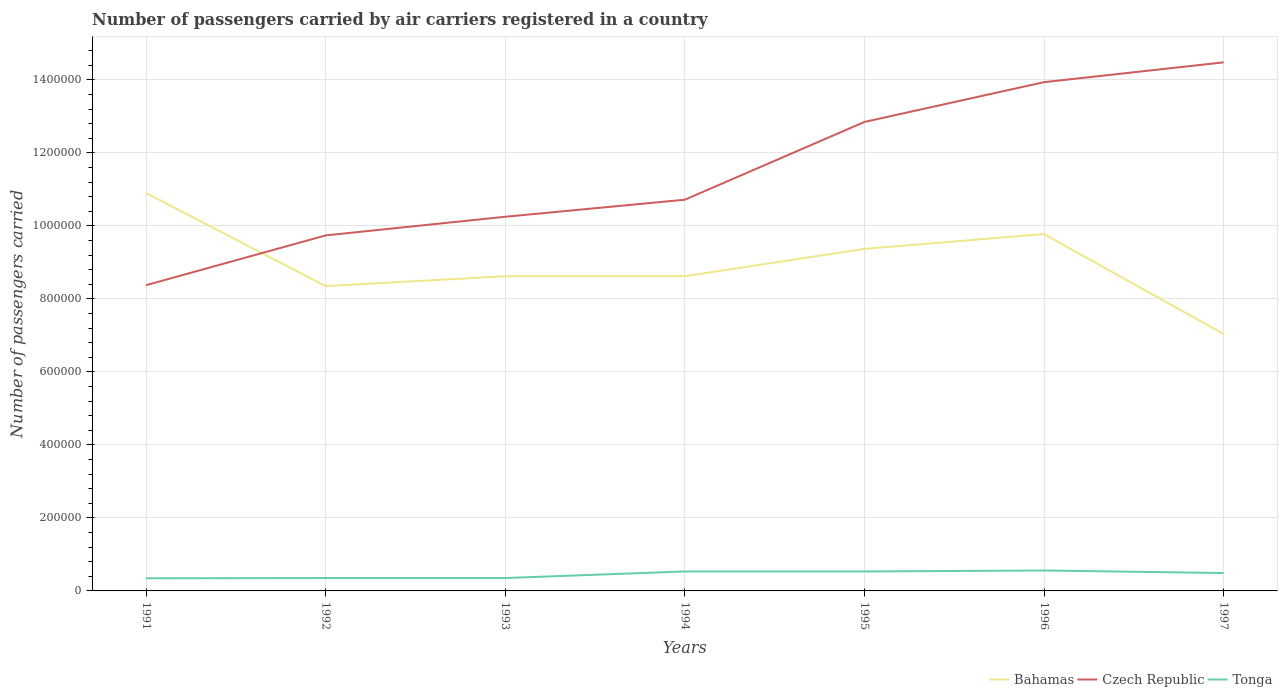How many different coloured lines are there?
Ensure brevity in your answer.  3. Does the line corresponding to Bahamas intersect with the line corresponding to Tonga?
Your response must be concise. No. Is the number of lines equal to the number of legend labels?
Your answer should be compact. Yes. Across all years, what is the maximum number of passengers carried by air carriers in Bahamas?
Provide a succinct answer. 7.04e+05. In which year was the number of passengers carried by air carriers in Bahamas maximum?
Provide a short and direct response. 1997. What is the total number of passengers carried by air carriers in Czech Republic in the graph?
Your answer should be compact. -2.13e+05. What is the difference between the highest and the second highest number of passengers carried by air carriers in Tonga?
Your answer should be compact. 2.14e+04. Is the number of passengers carried by air carriers in Bahamas strictly greater than the number of passengers carried by air carriers in Tonga over the years?
Your answer should be very brief. No. How many lines are there?
Make the answer very short. 3. Does the graph contain any zero values?
Offer a very short reply. No. Does the graph contain grids?
Give a very brief answer. Yes. Where does the legend appear in the graph?
Your response must be concise. Bottom right. What is the title of the graph?
Your answer should be compact. Number of passengers carried by air carriers registered in a country. What is the label or title of the X-axis?
Provide a short and direct response. Years. What is the label or title of the Y-axis?
Ensure brevity in your answer.  Number of passengers carried. What is the Number of passengers carried of Bahamas in 1991?
Keep it short and to the point. 1.09e+06. What is the Number of passengers carried of Czech Republic in 1991?
Provide a succinct answer. 8.37e+05. What is the Number of passengers carried of Tonga in 1991?
Provide a succinct answer. 3.46e+04. What is the Number of passengers carried of Bahamas in 1992?
Make the answer very short. 8.35e+05. What is the Number of passengers carried of Czech Republic in 1992?
Give a very brief answer. 9.74e+05. What is the Number of passengers carried of Tonga in 1992?
Ensure brevity in your answer.  3.53e+04. What is the Number of passengers carried of Bahamas in 1993?
Offer a terse response. 8.62e+05. What is the Number of passengers carried in Czech Republic in 1993?
Give a very brief answer. 1.02e+06. What is the Number of passengers carried of Tonga in 1993?
Offer a terse response. 3.53e+04. What is the Number of passengers carried in Bahamas in 1994?
Your response must be concise. 8.62e+05. What is the Number of passengers carried in Czech Republic in 1994?
Your answer should be compact. 1.07e+06. What is the Number of passengers carried in Tonga in 1994?
Your response must be concise. 5.33e+04. What is the Number of passengers carried of Bahamas in 1995?
Make the answer very short. 9.37e+05. What is the Number of passengers carried in Czech Republic in 1995?
Offer a terse response. 1.28e+06. What is the Number of passengers carried of Tonga in 1995?
Your response must be concise. 5.33e+04. What is the Number of passengers carried in Bahamas in 1996?
Make the answer very short. 9.78e+05. What is the Number of passengers carried in Czech Republic in 1996?
Your answer should be compact. 1.39e+06. What is the Number of passengers carried in Tonga in 1996?
Keep it short and to the point. 5.60e+04. What is the Number of passengers carried of Bahamas in 1997?
Offer a very short reply. 7.04e+05. What is the Number of passengers carried of Czech Republic in 1997?
Your answer should be very brief. 1.45e+06. What is the Number of passengers carried in Tonga in 1997?
Your response must be concise. 4.90e+04. Across all years, what is the maximum Number of passengers carried in Bahamas?
Your answer should be compact. 1.09e+06. Across all years, what is the maximum Number of passengers carried in Czech Republic?
Provide a short and direct response. 1.45e+06. Across all years, what is the maximum Number of passengers carried of Tonga?
Your response must be concise. 5.60e+04. Across all years, what is the minimum Number of passengers carried in Bahamas?
Your answer should be compact. 7.04e+05. Across all years, what is the minimum Number of passengers carried in Czech Republic?
Keep it short and to the point. 8.37e+05. Across all years, what is the minimum Number of passengers carried of Tonga?
Ensure brevity in your answer.  3.46e+04. What is the total Number of passengers carried in Bahamas in the graph?
Ensure brevity in your answer.  6.27e+06. What is the total Number of passengers carried in Czech Republic in the graph?
Keep it short and to the point. 8.03e+06. What is the total Number of passengers carried in Tonga in the graph?
Give a very brief answer. 3.17e+05. What is the difference between the Number of passengers carried of Bahamas in 1991 and that in 1992?
Provide a succinct answer. 2.55e+05. What is the difference between the Number of passengers carried of Czech Republic in 1991 and that in 1992?
Provide a succinct answer. -1.36e+05. What is the difference between the Number of passengers carried in Tonga in 1991 and that in 1992?
Your answer should be compact. -700. What is the difference between the Number of passengers carried of Bahamas in 1991 and that in 1993?
Offer a terse response. 2.28e+05. What is the difference between the Number of passengers carried of Czech Republic in 1991 and that in 1993?
Keep it short and to the point. -1.88e+05. What is the difference between the Number of passengers carried in Tonga in 1991 and that in 1993?
Your answer should be compact. -700. What is the difference between the Number of passengers carried in Bahamas in 1991 and that in 1994?
Your response must be concise. 2.28e+05. What is the difference between the Number of passengers carried of Czech Republic in 1991 and that in 1994?
Your response must be concise. -2.34e+05. What is the difference between the Number of passengers carried of Tonga in 1991 and that in 1994?
Provide a short and direct response. -1.87e+04. What is the difference between the Number of passengers carried in Bahamas in 1991 and that in 1995?
Give a very brief answer. 1.53e+05. What is the difference between the Number of passengers carried in Czech Republic in 1991 and that in 1995?
Your response must be concise. -4.47e+05. What is the difference between the Number of passengers carried in Tonga in 1991 and that in 1995?
Ensure brevity in your answer.  -1.87e+04. What is the difference between the Number of passengers carried in Bahamas in 1991 and that in 1996?
Give a very brief answer. 1.12e+05. What is the difference between the Number of passengers carried in Czech Republic in 1991 and that in 1996?
Ensure brevity in your answer.  -5.56e+05. What is the difference between the Number of passengers carried in Tonga in 1991 and that in 1996?
Provide a short and direct response. -2.14e+04. What is the difference between the Number of passengers carried in Bahamas in 1991 and that in 1997?
Your answer should be compact. 3.86e+05. What is the difference between the Number of passengers carried in Czech Republic in 1991 and that in 1997?
Keep it short and to the point. -6.10e+05. What is the difference between the Number of passengers carried in Tonga in 1991 and that in 1997?
Your answer should be very brief. -1.44e+04. What is the difference between the Number of passengers carried in Bahamas in 1992 and that in 1993?
Give a very brief answer. -2.70e+04. What is the difference between the Number of passengers carried of Czech Republic in 1992 and that in 1993?
Your answer should be compact. -5.11e+04. What is the difference between the Number of passengers carried in Tonga in 1992 and that in 1993?
Give a very brief answer. 0. What is the difference between the Number of passengers carried in Bahamas in 1992 and that in 1994?
Your answer should be compact. -2.70e+04. What is the difference between the Number of passengers carried of Czech Republic in 1992 and that in 1994?
Make the answer very short. -9.78e+04. What is the difference between the Number of passengers carried in Tonga in 1992 and that in 1994?
Provide a short and direct response. -1.80e+04. What is the difference between the Number of passengers carried of Bahamas in 1992 and that in 1995?
Provide a succinct answer. -1.02e+05. What is the difference between the Number of passengers carried of Czech Republic in 1992 and that in 1995?
Ensure brevity in your answer.  -3.11e+05. What is the difference between the Number of passengers carried in Tonga in 1992 and that in 1995?
Your response must be concise. -1.80e+04. What is the difference between the Number of passengers carried in Bahamas in 1992 and that in 1996?
Provide a short and direct response. -1.42e+05. What is the difference between the Number of passengers carried in Czech Republic in 1992 and that in 1996?
Ensure brevity in your answer.  -4.20e+05. What is the difference between the Number of passengers carried in Tonga in 1992 and that in 1996?
Keep it short and to the point. -2.07e+04. What is the difference between the Number of passengers carried of Bahamas in 1992 and that in 1997?
Offer a terse response. 1.31e+05. What is the difference between the Number of passengers carried in Czech Republic in 1992 and that in 1997?
Make the answer very short. -4.74e+05. What is the difference between the Number of passengers carried of Tonga in 1992 and that in 1997?
Your answer should be very brief. -1.37e+04. What is the difference between the Number of passengers carried of Bahamas in 1993 and that in 1994?
Ensure brevity in your answer.  0. What is the difference between the Number of passengers carried in Czech Republic in 1993 and that in 1994?
Offer a terse response. -4.67e+04. What is the difference between the Number of passengers carried in Tonga in 1993 and that in 1994?
Keep it short and to the point. -1.80e+04. What is the difference between the Number of passengers carried of Bahamas in 1993 and that in 1995?
Offer a very short reply. -7.49e+04. What is the difference between the Number of passengers carried of Czech Republic in 1993 and that in 1995?
Your response must be concise. -2.60e+05. What is the difference between the Number of passengers carried in Tonga in 1993 and that in 1995?
Provide a succinct answer. -1.80e+04. What is the difference between the Number of passengers carried in Bahamas in 1993 and that in 1996?
Offer a very short reply. -1.16e+05. What is the difference between the Number of passengers carried of Czech Republic in 1993 and that in 1996?
Offer a very short reply. -3.69e+05. What is the difference between the Number of passengers carried of Tonga in 1993 and that in 1996?
Give a very brief answer. -2.07e+04. What is the difference between the Number of passengers carried in Bahamas in 1993 and that in 1997?
Keep it short and to the point. 1.58e+05. What is the difference between the Number of passengers carried in Czech Republic in 1993 and that in 1997?
Keep it short and to the point. -4.23e+05. What is the difference between the Number of passengers carried in Tonga in 1993 and that in 1997?
Give a very brief answer. -1.37e+04. What is the difference between the Number of passengers carried of Bahamas in 1994 and that in 1995?
Ensure brevity in your answer.  -7.49e+04. What is the difference between the Number of passengers carried of Czech Republic in 1994 and that in 1995?
Keep it short and to the point. -2.13e+05. What is the difference between the Number of passengers carried of Tonga in 1994 and that in 1995?
Your response must be concise. 0. What is the difference between the Number of passengers carried in Bahamas in 1994 and that in 1996?
Keep it short and to the point. -1.16e+05. What is the difference between the Number of passengers carried in Czech Republic in 1994 and that in 1996?
Offer a very short reply. -3.22e+05. What is the difference between the Number of passengers carried of Tonga in 1994 and that in 1996?
Give a very brief answer. -2700. What is the difference between the Number of passengers carried in Bahamas in 1994 and that in 1997?
Your answer should be compact. 1.58e+05. What is the difference between the Number of passengers carried of Czech Republic in 1994 and that in 1997?
Keep it short and to the point. -3.76e+05. What is the difference between the Number of passengers carried of Tonga in 1994 and that in 1997?
Your answer should be compact. 4300. What is the difference between the Number of passengers carried in Bahamas in 1995 and that in 1996?
Make the answer very short. -4.06e+04. What is the difference between the Number of passengers carried in Czech Republic in 1995 and that in 1996?
Your response must be concise. -1.09e+05. What is the difference between the Number of passengers carried of Tonga in 1995 and that in 1996?
Provide a succinct answer. -2700. What is the difference between the Number of passengers carried in Bahamas in 1995 and that in 1997?
Offer a terse response. 2.33e+05. What is the difference between the Number of passengers carried of Czech Republic in 1995 and that in 1997?
Ensure brevity in your answer.  -1.63e+05. What is the difference between the Number of passengers carried of Tonga in 1995 and that in 1997?
Give a very brief answer. 4300. What is the difference between the Number of passengers carried of Bahamas in 1996 and that in 1997?
Your answer should be very brief. 2.74e+05. What is the difference between the Number of passengers carried of Czech Republic in 1996 and that in 1997?
Keep it short and to the point. -5.42e+04. What is the difference between the Number of passengers carried of Tonga in 1996 and that in 1997?
Provide a short and direct response. 7000. What is the difference between the Number of passengers carried in Bahamas in 1991 and the Number of passengers carried in Czech Republic in 1992?
Your answer should be compact. 1.16e+05. What is the difference between the Number of passengers carried in Bahamas in 1991 and the Number of passengers carried in Tonga in 1992?
Your answer should be very brief. 1.05e+06. What is the difference between the Number of passengers carried of Czech Republic in 1991 and the Number of passengers carried of Tonga in 1992?
Make the answer very short. 8.02e+05. What is the difference between the Number of passengers carried in Bahamas in 1991 and the Number of passengers carried in Czech Republic in 1993?
Make the answer very short. 6.51e+04. What is the difference between the Number of passengers carried in Bahamas in 1991 and the Number of passengers carried in Tonga in 1993?
Give a very brief answer. 1.05e+06. What is the difference between the Number of passengers carried of Czech Republic in 1991 and the Number of passengers carried of Tonga in 1993?
Your answer should be compact. 8.02e+05. What is the difference between the Number of passengers carried in Bahamas in 1991 and the Number of passengers carried in Czech Republic in 1994?
Make the answer very short. 1.84e+04. What is the difference between the Number of passengers carried in Bahamas in 1991 and the Number of passengers carried in Tonga in 1994?
Make the answer very short. 1.04e+06. What is the difference between the Number of passengers carried of Czech Republic in 1991 and the Number of passengers carried of Tonga in 1994?
Ensure brevity in your answer.  7.84e+05. What is the difference between the Number of passengers carried in Bahamas in 1991 and the Number of passengers carried in Czech Republic in 1995?
Provide a succinct answer. -1.95e+05. What is the difference between the Number of passengers carried of Bahamas in 1991 and the Number of passengers carried of Tonga in 1995?
Ensure brevity in your answer.  1.04e+06. What is the difference between the Number of passengers carried of Czech Republic in 1991 and the Number of passengers carried of Tonga in 1995?
Offer a terse response. 7.84e+05. What is the difference between the Number of passengers carried in Bahamas in 1991 and the Number of passengers carried in Czech Republic in 1996?
Make the answer very short. -3.04e+05. What is the difference between the Number of passengers carried in Bahamas in 1991 and the Number of passengers carried in Tonga in 1996?
Your response must be concise. 1.03e+06. What is the difference between the Number of passengers carried in Czech Republic in 1991 and the Number of passengers carried in Tonga in 1996?
Make the answer very short. 7.81e+05. What is the difference between the Number of passengers carried in Bahamas in 1991 and the Number of passengers carried in Czech Republic in 1997?
Your answer should be compact. -3.58e+05. What is the difference between the Number of passengers carried in Bahamas in 1991 and the Number of passengers carried in Tonga in 1997?
Ensure brevity in your answer.  1.04e+06. What is the difference between the Number of passengers carried of Czech Republic in 1991 and the Number of passengers carried of Tonga in 1997?
Your response must be concise. 7.88e+05. What is the difference between the Number of passengers carried in Bahamas in 1992 and the Number of passengers carried in Czech Republic in 1993?
Make the answer very short. -1.90e+05. What is the difference between the Number of passengers carried in Bahamas in 1992 and the Number of passengers carried in Tonga in 1993?
Keep it short and to the point. 8.00e+05. What is the difference between the Number of passengers carried in Czech Republic in 1992 and the Number of passengers carried in Tonga in 1993?
Keep it short and to the point. 9.38e+05. What is the difference between the Number of passengers carried in Bahamas in 1992 and the Number of passengers carried in Czech Republic in 1994?
Make the answer very short. -2.37e+05. What is the difference between the Number of passengers carried of Bahamas in 1992 and the Number of passengers carried of Tonga in 1994?
Keep it short and to the point. 7.82e+05. What is the difference between the Number of passengers carried of Czech Republic in 1992 and the Number of passengers carried of Tonga in 1994?
Provide a short and direct response. 9.20e+05. What is the difference between the Number of passengers carried in Bahamas in 1992 and the Number of passengers carried in Czech Republic in 1995?
Provide a succinct answer. -4.50e+05. What is the difference between the Number of passengers carried of Bahamas in 1992 and the Number of passengers carried of Tonga in 1995?
Your answer should be compact. 7.82e+05. What is the difference between the Number of passengers carried of Czech Republic in 1992 and the Number of passengers carried of Tonga in 1995?
Ensure brevity in your answer.  9.20e+05. What is the difference between the Number of passengers carried of Bahamas in 1992 and the Number of passengers carried of Czech Republic in 1996?
Provide a short and direct response. -5.59e+05. What is the difference between the Number of passengers carried in Bahamas in 1992 and the Number of passengers carried in Tonga in 1996?
Ensure brevity in your answer.  7.79e+05. What is the difference between the Number of passengers carried of Czech Republic in 1992 and the Number of passengers carried of Tonga in 1996?
Provide a succinct answer. 9.18e+05. What is the difference between the Number of passengers carried in Bahamas in 1992 and the Number of passengers carried in Czech Republic in 1997?
Your answer should be compact. -6.13e+05. What is the difference between the Number of passengers carried of Bahamas in 1992 and the Number of passengers carried of Tonga in 1997?
Provide a succinct answer. 7.86e+05. What is the difference between the Number of passengers carried of Czech Republic in 1992 and the Number of passengers carried of Tonga in 1997?
Your answer should be compact. 9.25e+05. What is the difference between the Number of passengers carried in Bahamas in 1993 and the Number of passengers carried in Czech Republic in 1994?
Offer a very short reply. -2.10e+05. What is the difference between the Number of passengers carried of Bahamas in 1993 and the Number of passengers carried of Tonga in 1994?
Your answer should be compact. 8.09e+05. What is the difference between the Number of passengers carried of Czech Republic in 1993 and the Number of passengers carried of Tonga in 1994?
Your answer should be compact. 9.72e+05. What is the difference between the Number of passengers carried in Bahamas in 1993 and the Number of passengers carried in Czech Republic in 1995?
Keep it short and to the point. -4.23e+05. What is the difference between the Number of passengers carried in Bahamas in 1993 and the Number of passengers carried in Tonga in 1995?
Ensure brevity in your answer.  8.09e+05. What is the difference between the Number of passengers carried of Czech Republic in 1993 and the Number of passengers carried of Tonga in 1995?
Offer a terse response. 9.72e+05. What is the difference between the Number of passengers carried in Bahamas in 1993 and the Number of passengers carried in Czech Republic in 1996?
Offer a very short reply. -5.32e+05. What is the difference between the Number of passengers carried in Bahamas in 1993 and the Number of passengers carried in Tonga in 1996?
Your response must be concise. 8.06e+05. What is the difference between the Number of passengers carried in Czech Republic in 1993 and the Number of passengers carried in Tonga in 1996?
Keep it short and to the point. 9.69e+05. What is the difference between the Number of passengers carried in Bahamas in 1993 and the Number of passengers carried in Czech Republic in 1997?
Offer a very short reply. -5.86e+05. What is the difference between the Number of passengers carried in Bahamas in 1993 and the Number of passengers carried in Tonga in 1997?
Make the answer very short. 8.13e+05. What is the difference between the Number of passengers carried of Czech Republic in 1993 and the Number of passengers carried of Tonga in 1997?
Keep it short and to the point. 9.76e+05. What is the difference between the Number of passengers carried in Bahamas in 1994 and the Number of passengers carried in Czech Republic in 1995?
Your answer should be very brief. -4.23e+05. What is the difference between the Number of passengers carried in Bahamas in 1994 and the Number of passengers carried in Tonga in 1995?
Ensure brevity in your answer.  8.09e+05. What is the difference between the Number of passengers carried in Czech Republic in 1994 and the Number of passengers carried in Tonga in 1995?
Offer a terse response. 1.02e+06. What is the difference between the Number of passengers carried of Bahamas in 1994 and the Number of passengers carried of Czech Republic in 1996?
Your response must be concise. -5.32e+05. What is the difference between the Number of passengers carried of Bahamas in 1994 and the Number of passengers carried of Tonga in 1996?
Make the answer very short. 8.06e+05. What is the difference between the Number of passengers carried in Czech Republic in 1994 and the Number of passengers carried in Tonga in 1996?
Offer a terse response. 1.02e+06. What is the difference between the Number of passengers carried of Bahamas in 1994 and the Number of passengers carried of Czech Republic in 1997?
Keep it short and to the point. -5.86e+05. What is the difference between the Number of passengers carried of Bahamas in 1994 and the Number of passengers carried of Tonga in 1997?
Your response must be concise. 8.13e+05. What is the difference between the Number of passengers carried of Czech Republic in 1994 and the Number of passengers carried of Tonga in 1997?
Keep it short and to the point. 1.02e+06. What is the difference between the Number of passengers carried of Bahamas in 1995 and the Number of passengers carried of Czech Republic in 1996?
Give a very brief answer. -4.57e+05. What is the difference between the Number of passengers carried of Bahamas in 1995 and the Number of passengers carried of Tonga in 1996?
Provide a short and direct response. 8.81e+05. What is the difference between the Number of passengers carried of Czech Republic in 1995 and the Number of passengers carried of Tonga in 1996?
Give a very brief answer. 1.23e+06. What is the difference between the Number of passengers carried in Bahamas in 1995 and the Number of passengers carried in Czech Republic in 1997?
Ensure brevity in your answer.  -5.11e+05. What is the difference between the Number of passengers carried in Bahamas in 1995 and the Number of passengers carried in Tonga in 1997?
Offer a terse response. 8.88e+05. What is the difference between the Number of passengers carried in Czech Republic in 1995 and the Number of passengers carried in Tonga in 1997?
Ensure brevity in your answer.  1.24e+06. What is the difference between the Number of passengers carried in Bahamas in 1996 and the Number of passengers carried in Czech Republic in 1997?
Ensure brevity in your answer.  -4.70e+05. What is the difference between the Number of passengers carried of Bahamas in 1996 and the Number of passengers carried of Tonga in 1997?
Keep it short and to the point. 9.28e+05. What is the difference between the Number of passengers carried in Czech Republic in 1996 and the Number of passengers carried in Tonga in 1997?
Give a very brief answer. 1.34e+06. What is the average Number of passengers carried in Bahamas per year?
Your answer should be very brief. 8.95e+05. What is the average Number of passengers carried of Czech Republic per year?
Offer a very short reply. 1.15e+06. What is the average Number of passengers carried of Tonga per year?
Ensure brevity in your answer.  4.53e+04. In the year 1991, what is the difference between the Number of passengers carried of Bahamas and Number of passengers carried of Czech Republic?
Your response must be concise. 2.53e+05. In the year 1991, what is the difference between the Number of passengers carried in Bahamas and Number of passengers carried in Tonga?
Offer a terse response. 1.06e+06. In the year 1991, what is the difference between the Number of passengers carried of Czech Republic and Number of passengers carried of Tonga?
Offer a terse response. 8.03e+05. In the year 1992, what is the difference between the Number of passengers carried of Bahamas and Number of passengers carried of Czech Republic?
Your answer should be compact. -1.39e+05. In the year 1992, what is the difference between the Number of passengers carried of Bahamas and Number of passengers carried of Tonga?
Your response must be concise. 8.00e+05. In the year 1992, what is the difference between the Number of passengers carried of Czech Republic and Number of passengers carried of Tonga?
Offer a very short reply. 9.38e+05. In the year 1993, what is the difference between the Number of passengers carried in Bahamas and Number of passengers carried in Czech Republic?
Give a very brief answer. -1.63e+05. In the year 1993, what is the difference between the Number of passengers carried of Bahamas and Number of passengers carried of Tonga?
Ensure brevity in your answer.  8.27e+05. In the year 1993, what is the difference between the Number of passengers carried of Czech Republic and Number of passengers carried of Tonga?
Your answer should be very brief. 9.90e+05. In the year 1994, what is the difference between the Number of passengers carried in Bahamas and Number of passengers carried in Czech Republic?
Your answer should be very brief. -2.10e+05. In the year 1994, what is the difference between the Number of passengers carried of Bahamas and Number of passengers carried of Tonga?
Your answer should be compact. 8.09e+05. In the year 1994, what is the difference between the Number of passengers carried of Czech Republic and Number of passengers carried of Tonga?
Keep it short and to the point. 1.02e+06. In the year 1995, what is the difference between the Number of passengers carried of Bahamas and Number of passengers carried of Czech Republic?
Your answer should be very brief. -3.48e+05. In the year 1995, what is the difference between the Number of passengers carried in Bahamas and Number of passengers carried in Tonga?
Offer a terse response. 8.84e+05. In the year 1995, what is the difference between the Number of passengers carried in Czech Republic and Number of passengers carried in Tonga?
Provide a succinct answer. 1.23e+06. In the year 1996, what is the difference between the Number of passengers carried in Bahamas and Number of passengers carried in Czech Republic?
Make the answer very short. -4.16e+05. In the year 1996, what is the difference between the Number of passengers carried in Bahamas and Number of passengers carried in Tonga?
Provide a short and direct response. 9.22e+05. In the year 1996, what is the difference between the Number of passengers carried in Czech Republic and Number of passengers carried in Tonga?
Your answer should be very brief. 1.34e+06. In the year 1997, what is the difference between the Number of passengers carried of Bahamas and Number of passengers carried of Czech Republic?
Your response must be concise. -7.44e+05. In the year 1997, what is the difference between the Number of passengers carried of Bahamas and Number of passengers carried of Tonga?
Ensure brevity in your answer.  6.55e+05. In the year 1997, what is the difference between the Number of passengers carried of Czech Republic and Number of passengers carried of Tonga?
Ensure brevity in your answer.  1.40e+06. What is the ratio of the Number of passengers carried in Bahamas in 1991 to that in 1992?
Make the answer very short. 1.31. What is the ratio of the Number of passengers carried of Czech Republic in 1991 to that in 1992?
Keep it short and to the point. 0.86. What is the ratio of the Number of passengers carried of Tonga in 1991 to that in 1992?
Keep it short and to the point. 0.98. What is the ratio of the Number of passengers carried of Bahamas in 1991 to that in 1993?
Give a very brief answer. 1.26. What is the ratio of the Number of passengers carried in Czech Republic in 1991 to that in 1993?
Provide a succinct answer. 0.82. What is the ratio of the Number of passengers carried in Tonga in 1991 to that in 1993?
Ensure brevity in your answer.  0.98. What is the ratio of the Number of passengers carried in Bahamas in 1991 to that in 1994?
Keep it short and to the point. 1.26. What is the ratio of the Number of passengers carried in Czech Republic in 1991 to that in 1994?
Make the answer very short. 0.78. What is the ratio of the Number of passengers carried in Tonga in 1991 to that in 1994?
Ensure brevity in your answer.  0.65. What is the ratio of the Number of passengers carried of Bahamas in 1991 to that in 1995?
Offer a very short reply. 1.16. What is the ratio of the Number of passengers carried of Czech Republic in 1991 to that in 1995?
Your response must be concise. 0.65. What is the ratio of the Number of passengers carried in Tonga in 1991 to that in 1995?
Provide a short and direct response. 0.65. What is the ratio of the Number of passengers carried of Bahamas in 1991 to that in 1996?
Provide a short and direct response. 1.12. What is the ratio of the Number of passengers carried of Czech Republic in 1991 to that in 1996?
Provide a succinct answer. 0.6. What is the ratio of the Number of passengers carried of Tonga in 1991 to that in 1996?
Offer a very short reply. 0.62. What is the ratio of the Number of passengers carried in Bahamas in 1991 to that in 1997?
Your response must be concise. 1.55. What is the ratio of the Number of passengers carried of Czech Republic in 1991 to that in 1997?
Give a very brief answer. 0.58. What is the ratio of the Number of passengers carried of Tonga in 1991 to that in 1997?
Your answer should be very brief. 0.71. What is the ratio of the Number of passengers carried of Bahamas in 1992 to that in 1993?
Ensure brevity in your answer.  0.97. What is the ratio of the Number of passengers carried of Czech Republic in 1992 to that in 1993?
Your answer should be very brief. 0.95. What is the ratio of the Number of passengers carried in Tonga in 1992 to that in 1993?
Your answer should be very brief. 1. What is the ratio of the Number of passengers carried in Bahamas in 1992 to that in 1994?
Provide a short and direct response. 0.97. What is the ratio of the Number of passengers carried of Czech Republic in 1992 to that in 1994?
Give a very brief answer. 0.91. What is the ratio of the Number of passengers carried in Tonga in 1992 to that in 1994?
Your response must be concise. 0.66. What is the ratio of the Number of passengers carried of Bahamas in 1992 to that in 1995?
Your answer should be compact. 0.89. What is the ratio of the Number of passengers carried in Czech Republic in 1992 to that in 1995?
Your response must be concise. 0.76. What is the ratio of the Number of passengers carried in Tonga in 1992 to that in 1995?
Offer a very short reply. 0.66. What is the ratio of the Number of passengers carried in Bahamas in 1992 to that in 1996?
Provide a short and direct response. 0.85. What is the ratio of the Number of passengers carried in Czech Republic in 1992 to that in 1996?
Your answer should be very brief. 0.7. What is the ratio of the Number of passengers carried of Tonga in 1992 to that in 1996?
Provide a short and direct response. 0.63. What is the ratio of the Number of passengers carried of Bahamas in 1992 to that in 1997?
Ensure brevity in your answer.  1.19. What is the ratio of the Number of passengers carried of Czech Republic in 1992 to that in 1997?
Provide a short and direct response. 0.67. What is the ratio of the Number of passengers carried in Tonga in 1992 to that in 1997?
Your answer should be very brief. 0.72. What is the ratio of the Number of passengers carried in Czech Republic in 1993 to that in 1994?
Give a very brief answer. 0.96. What is the ratio of the Number of passengers carried in Tonga in 1993 to that in 1994?
Ensure brevity in your answer.  0.66. What is the ratio of the Number of passengers carried in Bahamas in 1993 to that in 1995?
Give a very brief answer. 0.92. What is the ratio of the Number of passengers carried in Czech Republic in 1993 to that in 1995?
Your response must be concise. 0.8. What is the ratio of the Number of passengers carried in Tonga in 1993 to that in 1995?
Ensure brevity in your answer.  0.66. What is the ratio of the Number of passengers carried in Bahamas in 1993 to that in 1996?
Offer a terse response. 0.88. What is the ratio of the Number of passengers carried of Czech Republic in 1993 to that in 1996?
Provide a succinct answer. 0.74. What is the ratio of the Number of passengers carried in Tonga in 1993 to that in 1996?
Provide a short and direct response. 0.63. What is the ratio of the Number of passengers carried in Bahamas in 1993 to that in 1997?
Your answer should be compact. 1.23. What is the ratio of the Number of passengers carried of Czech Republic in 1993 to that in 1997?
Keep it short and to the point. 0.71. What is the ratio of the Number of passengers carried in Tonga in 1993 to that in 1997?
Provide a succinct answer. 0.72. What is the ratio of the Number of passengers carried of Bahamas in 1994 to that in 1995?
Your answer should be very brief. 0.92. What is the ratio of the Number of passengers carried in Czech Republic in 1994 to that in 1995?
Your answer should be very brief. 0.83. What is the ratio of the Number of passengers carried of Tonga in 1994 to that in 1995?
Make the answer very short. 1. What is the ratio of the Number of passengers carried in Bahamas in 1994 to that in 1996?
Keep it short and to the point. 0.88. What is the ratio of the Number of passengers carried of Czech Republic in 1994 to that in 1996?
Give a very brief answer. 0.77. What is the ratio of the Number of passengers carried of Tonga in 1994 to that in 1996?
Your answer should be very brief. 0.95. What is the ratio of the Number of passengers carried of Bahamas in 1994 to that in 1997?
Give a very brief answer. 1.23. What is the ratio of the Number of passengers carried of Czech Republic in 1994 to that in 1997?
Offer a very short reply. 0.74. What is the ratio of the Number of passengers carried of Tonga in 1994 to that in 1997?
Your response must be concise. 1.09. What is the ratio of the Number of passengers carried of Bahamas in 1995 to that in 1996?
Your response must be concise. 0.96. What is the ratio of the Number of passengers carried in Czech Republic in 1995 to that in 1996?
Your response must be concise. 0.92. What is the ratio of the Number of passengers carried in Tonga in 1995 to that in 1996?
Keep it short and to the point. 0.95. What is the ratio of the Number of passengers carried of Bahamas in 1995 to that in 1997?
Offer a terse response. 1.33. What is the ratio of the Number of passengers carried of Czech Republic in 1995 to that in 1997?
Provide a short and direct response. 0.89. What is the ratio of the Number of passengers carried in Tonga in 1995 to that in 1997?
Make the answer very short. 1.09. What is the ratio of the Number of passengers carried of Bahamas in 1996 to that in 1997?
Your answer should be compact. 1.39. What is the ratio of the Number of passengers carried in Czech Republic in 1996 to that in 1997?
Keep it short and to the point. 0.96. What is the difference between the highest and the second highest Number of passengers carried of Bahamas?
Make the answer very short. 1.12e+05. What is the difference between the highest and the second highest Number of passengers carried of Czech Republic?
Offer a terse response. 5.42e+04. What is the difference between the highest and the second highest Number of passengers carried in Tonga?
Provide a succinct answer. 2700. What is the difference between the highest and the lowest Number of passengers carried in Bahamas?
Ensure brevity in your answer.  3.86e+05. What is the difference between the highest and the lowest Number of passengers carried of Czech Republic?
Your response must be concise. 6.10e+05. What is the difference between the highest and the lowest Number of passengers carried of Tonga?
Offer a terse response. 2.14e+04. 